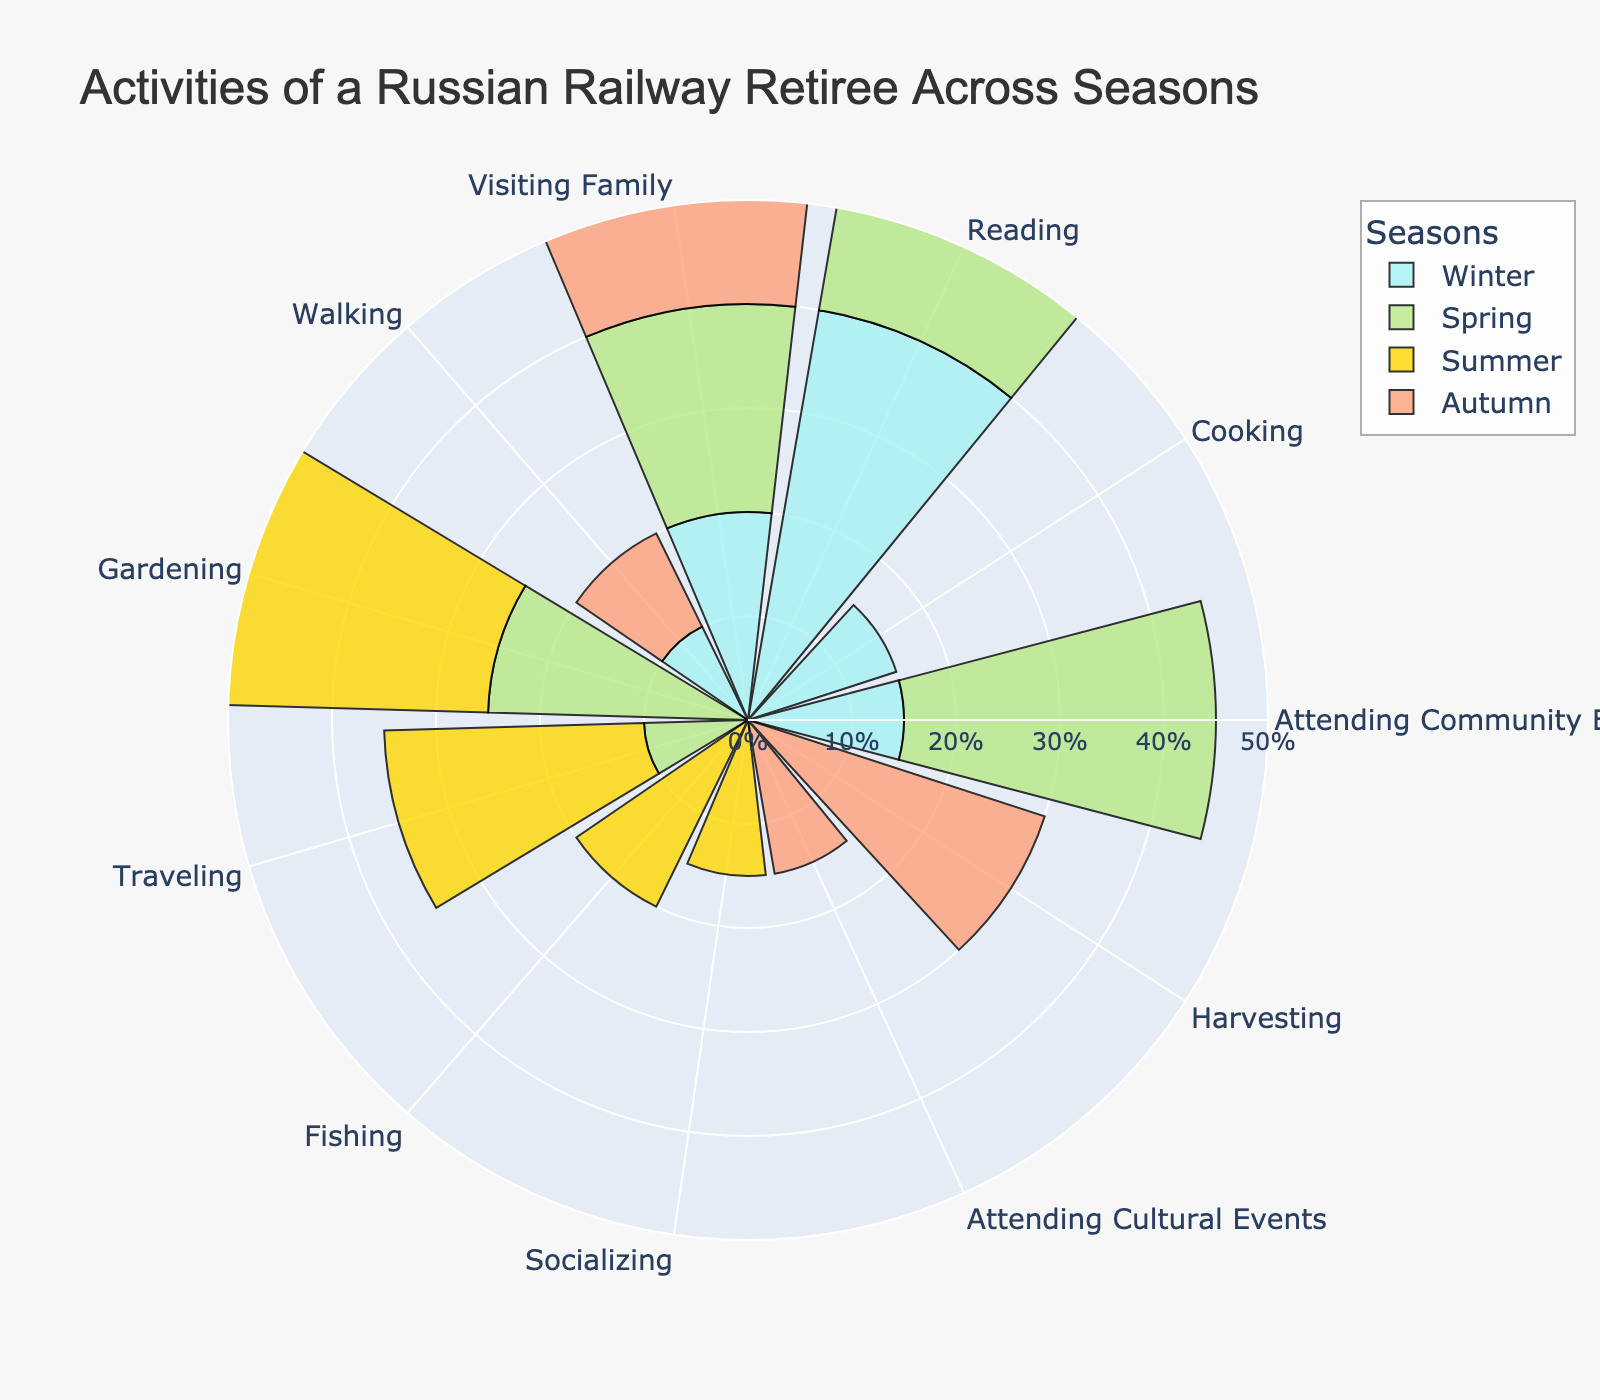What is the most common activity in Winter? The activity with the highest percentage in Winter is "Reading" with 40%.
Answer: Reading Which is the more popular activity in Spring: Gardening or Traveling? In Spring, Gardening is at 25% while Traveling is at 10%. Comparing these values, Gardening is more popular.
Answer: Gardening How much more popular is Reading in Winter compared to Summer? Reading in Winter is 40% and in Summer is 10%. The difference is 40% - 10% = 30%.
Answer: 30% Which season has the highest percentage of Socializing? Socializing is only listed in Summer with 15%. Therefore, Summer has the highest percentage for Socializing.
Answer: Summer Compare the percentage of Visiting Family in Spring and Autumn. Which season has a higher percentage, and by how much? Visiting Family in Spring is 20% and in Autumn is also 20%. There is no difference between the two seasons.
Answer: Equal What percentage of activities is dedicated to Gardening in Summer? The percentage for Gardening in Summer is 30%.
Answer: 30% List all activities and their percentages for Autumn. Autumn includes: Harvesting 30%, Visiting Family 20%, Reading 25%, Attending Cultural Events 15%, and Walking 10%.
Answer: Harvesting 30%, Visiting Family 20%, Reading 25%, Attending Cultural Events 15%, Walking 10% How does the percentage of Traveling change from Spring to Summer? Traveling in Spring is 10% and increases to 25% in Summer, an increase of 15%.
Answer: Increase 15% Which season has the highest variety in activities, based on the number of different activities? Both Spring and Winter have 5 different activities each, while Summer and Autumn have 5 as well. Therefore, all seasons have the same variety of activities.
Answer: Equal variety How does the overall percentage of attending events (combining community and cultural) in Spring compare to that in Winter? In Spring, only Attending Community Events is listed (30%), while in Winter, Attending Community Events is 15%. Spring: 30%, Winter: 15%. The combined total for participating events in Spring is higher by 15%.
Answer: Spring has 15% more 